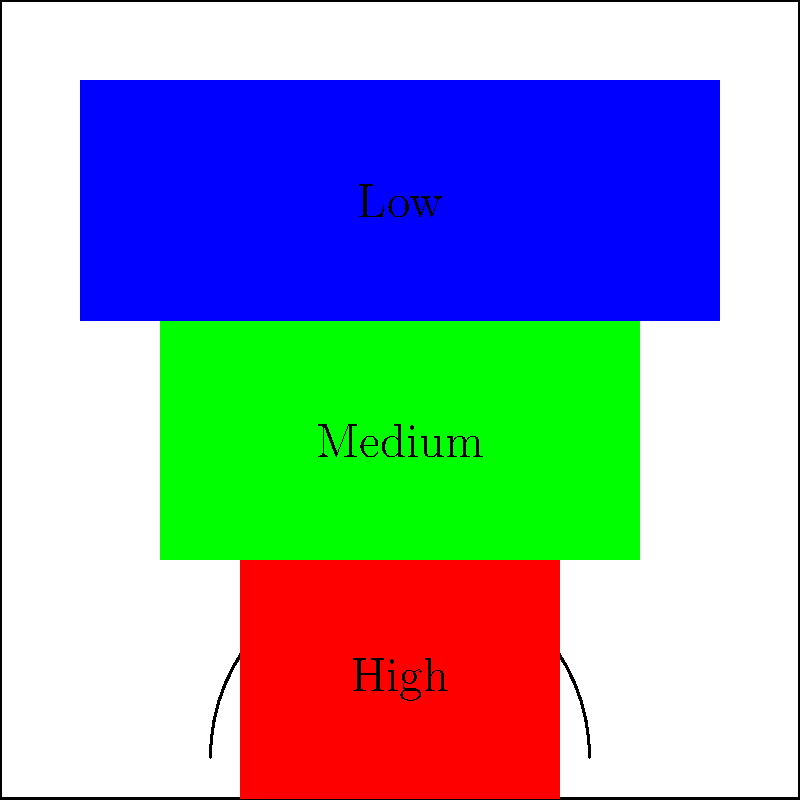Based on the player positioning heatmap shown above, which machine learning model would be most appropriate for predicting shot accuracy, and why? To answer this question, let's consider the characteristics of the data and the problem at hand:

1. Data representation: The heatmap shows discrete regions on a basketball court, each associated with a different level of shot accuracy (high, medium, low).

2. Input features: The input would be the player's position on the court (x and y coordinates).

3. Output: The model needs to predict shot accuracy, which can be treated as either a categorical (high, medium, low) or continuous (percentage) variable.

4. Decision boundaries: The regions in the heatmap have clear, non-linear boundaries.

5. Interpretability: As a sports analyst, you might need to explain the model's decisions to your audience.

Considering these factors, the most appropriate machine learning model would be a Decision Tree or Random Forest. Here's why:

1. Decision Trees can handle non-linear decision boundaries, which is crucial given the distinct regions in the heatmap.

2. They can easily handle both categorical and continuous outputs, allowing flexibility in how we define shot accuracy.

3. Random Forests, an ensemble of Decision Trees, can provide even better accuracy and robustness.

4. These models are interpretable, allowing you to explain which factors (court positions) contribute most to the predictions.

5. They can handle the discrete nature of the regions without requiring complex feature engineering.

6. Decision Trees and Random Forests can capture the hierarchical nature of the shot accuracy zones (e.g., closer to the basket generally means higher accuracy).

While other models like Neural Networks could potentially work, they would be more complex and less interpretable, which might not be ideal for a sports analyst needing to explain predictions to a general audience.
Answer: Decision Tree or Random Forest 